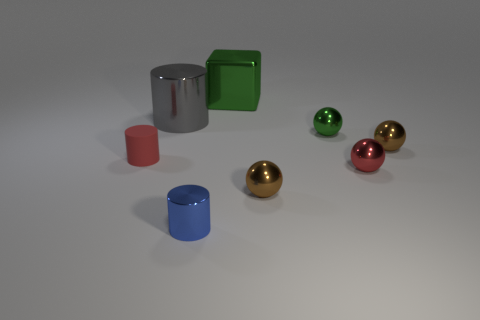Subtract 1 balls. How many balls are left? 3 Add 1 big green shiny objects. How many objects exist? 9 Subtract all cylinders. How many objects are left? 5 Add 2 small blue metallic cylinders. How many small blue metallic cylinders exist? 3 Subtract 0 cyan cylinders. How many objects are left? 8 Subtract all big yellow rubber objects. Subtract all red rubber objects. How many objects are left? 7 Add 6 tiny red cylinders. How many tiny red cylinders are left? 7 